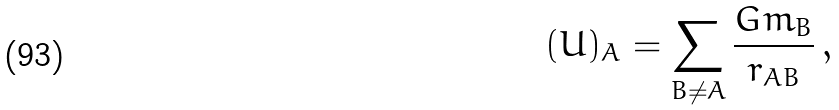<formula> <loc_0><loc_0><loc_500><loc_500>( U ) _ { A } = \sum _ { B \not = A } \frac { G m _ { B } } { r _ { A B } } \, ,</formula> 